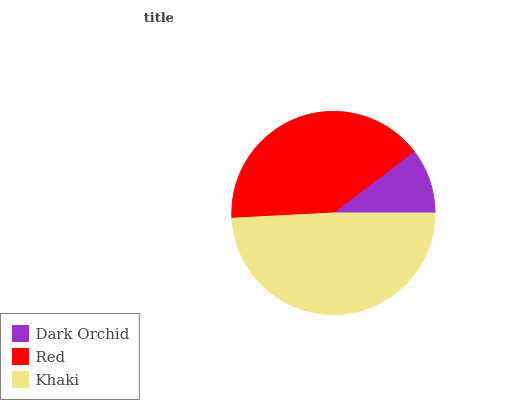Is Dark Orchid the minimum?
Answer yes or no. Yes. Is Khaki the maximum?
Answer yes or no. Yes. Is Red the minimum?
Answer yes or no. No. Is Red the maximum?
Answer yes or no. No. Is Red greater than Dark Orchid?
Answer yes or no. Yes. Is Dark Orchid less than Red?
Answer yes or no. Yes. Is Dark Orchid greater than Red?
Answer yes or no. No. Is Red less than Dark Orchid?
Answer yes or no. No. Is Red the high median?
Answer yes or no. Yes. Is Red the low median?
Answer yes or no. Yes. Is Dark Orchid the high median?
Answer yes or no. No. Is Dark Orchid the low median?
Answer yes or no. No. 